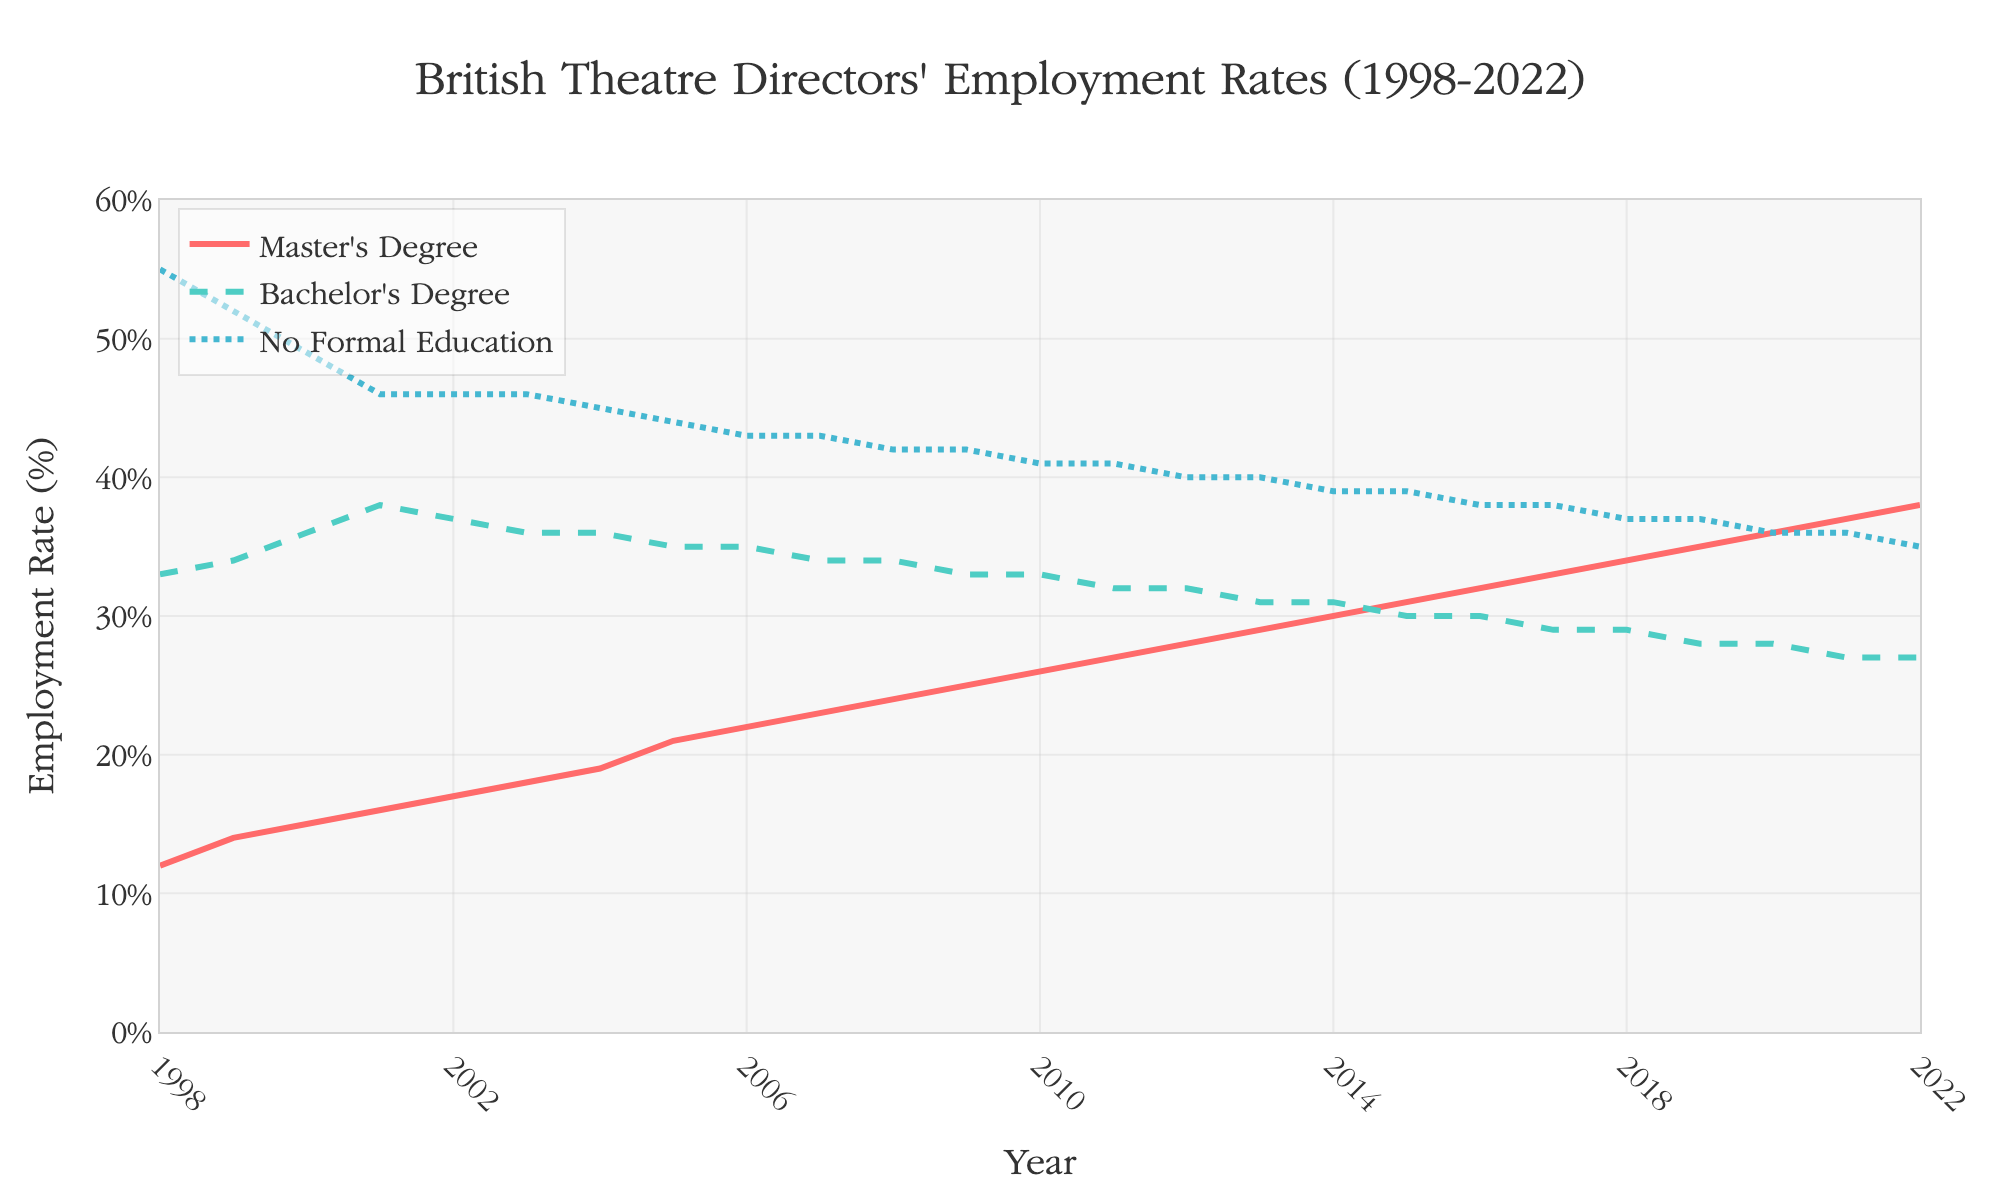What is the overall trend in employment rates for British theatre directors with a Master's degree from 1998 to 2022? Observing the plot, we can see that the line representing Master's degree trends consistently upward from 12% in 1998 to 38% in 2022.
Answer: Increasing In which year does the employment rate for directors with a Bachelor's degree first show a notable decline? The line for Bachelor's degree shows that the first notable decline occurs between the years 2010 and 2011, where the employment rate drops from 33% to 32%.
Answer: 2011 What was the employment rate for directors with no formal education in 1998 and how does it compare to 2022? In 1998, the employment rate for directors with no formal education was 55%. By 2022, this rate declined to 35%. The rate decreased by 20 percentage points over the 24-year period.
Answer: 55% in 1998, 35% in 2022 Which group had the highest employment rate in 2005, and what was that rate? The plot shows that in 2005, directors with no formal education had the highest employment rate at 44%.
Answer: No formal education, 44% What is the average employment rate for directors with a Master's degree from 1998 to 2022? Sum the employment rates for directors with a Master's degree for all 25 years and divide by 25. (12+14+15+16+17+18+19+21+22+23+24+25+26+27+28+29+30+31+32+33+34+35+36+37+38)/25 = 25.6
Answer: 25.6% How did the employment rate for directors with a Bachelor's degree change between 2010 and 2020? The employment rate for directors with a Bachelor's degree in 2010 was 33%. In 2020, it was 28%. Subtracting these gives a change of 33% - 28% = 5%.
Answer: Decreased by 5% Between which consecutive years did the employment rate for directors with a Master's degree increase the most? The largest single-year increase for Master's degree occurred between 2004 and 2005, where the employment rate increased from 19% to 21%.
Answer: 2004 to 2005 What percentage point difference is there between the employment rates of Bachelor's degree and no formal education in 2022? In 2022, the employment rate for Bachelor's degree is 27% and for no formal education is 35%. The difference is 35% - 27% = 8%.
Answer: 8% 